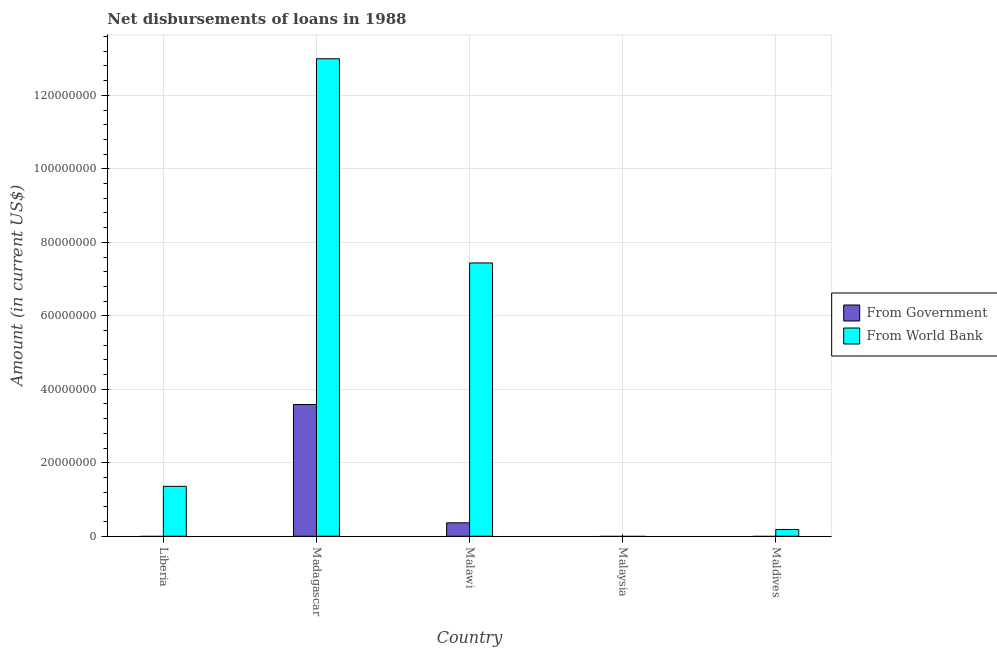Are the number of bars per tick equal to the number of legend labels?
Keep it short and to the point. No. Are the number of bars on each tick of the X-axis equal?
Ensure brevity in your answer.  No. How many bars are there on the 1st tick from the left?
Offer a very short reply. 1. How many bars are there on the 1st tick from the right?
Your answer should be very brief. 1. What is the label of the 5th group of bars from the left?
Ensure brevity in your answer.  Maldives. In how many cases, is the number of bars for a given country not equal to the number of legend labels?
Your answer should be compact. 3. What is the net disbursements of loan from government in Maldives?
Make the answer very short. 0. Across all countries, what is the maximum net disbursements of loan from world bank?
Your answer should be very brief. 1.30e+08. In which country was the net disbursements of loan from government maximum?
Offer a terse response. Madagascar. What is the total net disbursements of loan from government in the graph?
Offer a terse response. 3.95e+07. What is the difference between the net disbursements of loan from world bank in Madagascar and that in Malawi?
Make the answer very short. 5.56e+07. What is the difference between the net disbursements of loan from government in Maldives and the net disbursements of loan from world bank in Malawi?
Make the answer very short. -7.44e+07. What is the average net disbursements of loan from government per country?
Give a very brief answer. 7.90e+06. What is the difference between the net disbursements of loan from government and net disbursements of loan from world bank in Malawi?
Offer a very short reply. -7.07e+07. In how many countries, is the net disbursements of loan from government greater than 112000000 US$?
Keep it short and to the point. 0. What is the ratio of the net disbursements of loan from world bank in Malawi to that in Maldives?
Ensure brevity in your answer.  40.38. Is the net disbursements of loan from world bank in Malawi less than that in Maldives?
Your answer should be compact. No. Is the difference between the net disbursements of loan from world bank in Madagascar and Malawi greater than the difference between the net disbursements of loan from government in Madagascar and Malawi?
Provide a short and direct response. Yes. What is the difference between the highest and the second highest net disbursements of loan from world bank?
Offer a terse response. 5.56e+07. What is the difference between the highest and the lowest net disbursements of loan from world bank?
Keep it short and to the point. 1.30e+08. In how many countries, is the net disbursements of loan from government greater than the average net disbursements of loan from government taken over all countries?
Make the answer very short. 1. Is the sum of the net disbursements of loan from world bank in Malawi and Maldives greater than the maximum net disbursements of loan from government across all countries?
Provide a succinct answer. Yes. How many bars are there?
Your answer should be compact. 6. How many countries are there in the graph?
Make the answer very short. 5. What is the difference between two consecutive major ticks on the Y-axis?
Provide a succinct answer. 2.00e+07. Does the graph contain grids?
Your response must be concise. Yes. Where does the legend appear in the graph?
Offer a very short reply. Center right. How many legend labels are there?
Give a very brief answer. 2. How are the legend labels stacked?
Ensure brevity in your answer.  Vertical. What is the title of the graph?
Offer a terse response. Net disbursements of loans in 1988. Does "Age 65(female)" appear as one of the legend labels in the graph?
Your response must be concise. No. What is the label or title of the Y-axis?
Make the answer very short. Amount (in current US$). What is the Amount (in current US$) in From World Bank in Liberia?
Your answer should be compact. 1.36e+07. What is the Amount (in current US$) in From Government in Madagascar?
Keep it short and to the point. 3.59e+07. What is the Amount (in current US$) in From World Bank in Madagascar?
Your answer should be compact. 1.30e+08. What is the Amount (in current US$) in From Government in Malawi?
Provide a short and direct response. 3.66e+06. What is the Amount (in current US$) of From World Bank in Malawi?
Keep it short and to the point. 7.44e+07. What is the Amount (in current US$) of From Government in Maldives?
Offer a terse response. 0. What is the Amount (in current US$) of From World Bank in Maldives?
Ensure brevity in your answer.  1.84e+06. Across all countries, what is the maximum Amount (in current US$) of From Government?
Keep it short and to the point. 3.59e+07. Across all countries, what is the maximum Amount (in current US$) of From World Bank?
Provide a short and direct response. 1.30e+08. What is the total Amount (in current US$) in From Government in the graph?
Provide a short and direct response. 3.95e+07. What is the total Amount (in current US$) of From World Bank in the graph?
Make the answer very short. 2.20e+08. What is the difference between the Amount (in current US$) in From World Bank in Liberia and that in Madagascar?
Offer a terse response. -1.16e+08. What is the difference between the Amount (in current US$) in From World Bank in Liberia and that in Malawi?
Offer a terse response. -6.08e+07. What is the difference between the Amount (in current US$) of From World Bank in Liberia and that in Maldives?
Give a very brief answer. 1.17e+07. What is the difference between the Amount (in current US$) of From Government in Madagascar and that in Malawi?
Provide a short and direct response. 3.22e+07. What is the difference between the Amount (in current US$) in From World Bank in Madagascar and that in Malawi?
Keep it short and to the point. 5.56e+07. What is the difference between the Amount (in current US$) in From World Bank in Madagascar and that in Maldives?
Give a very brief answer. 1.28e+08. What is the difference between the Amount (in current US$) of From World Bank in Malawi and that in Maldives?
Give a very brief answer. 7.25e+07. What is the difference between the Amount (in current US$) of From Government in Madagascar and the Amount (in current US$) of From World Bank in Malawi?
Provide a short and direct response. -3.85e+07. What is the difference between the Amount (in current US$) of From Government in Madagascar and the Amount (in current US$) of From World Bank in Maldives?
Provide a short and direct response. 3.40e+07. What is the difference between the Amount (in current US$) in From Government in Malawi and the Amount (in current US$) in From World Bank in Maldives?
Offer a very short reply. 1.82e+06. What is the average Amount (in current US$) of From Government per country?
Your answer should be very brief. 7.90e+06. What is the average Amount (in current US$) of From World Bank per country?
Offer a terse response. 4.40e+07. What is the difference between the Amount (in current US$) in From Government and Amount (in current US$) in From World Bank in Madagascar?
Offer a very short reply. -9.41e+07. What is the difference between the Amount (in current US$) of From Government and Amount (in current US$) of From World Bank in Malawi?
Ensure brevity in your answer.  -7.07e+07. What is the ratio of the Amount (in current US$) of From World Bank in Liberia to that in Madagascar?
Make the answer very short. 0.1. What is the ratio of the Amount (in current US$) in From World Bank in Liberia to that in Malawi?
Give a very brief answer. 0.18. What is the ratio of the Amount (in current US$) of From World Bank in Liberia to that in Maldives?
Provide a short and direct response. 7.37. What is the ratio of the Amount (in current US$) in From Government in Madagascar to that in Malawi?
Your response must be concise. 9.8. What is the ratio of the Amount (in current US$) in From World Bank in Madagascar to that in Malawi?
Make the answer very short. 1.75. What is the ratio of the Amount (in current US$) of From World Bank in Madagascar to that in Maldives?
Provide a succinct answer. 70.55. What is the ratio of the Amount (in current US$) in From World Bank in Malawi to that in Maldives?
Your answer should be very brief. 40.38. What is the difference between the highest and the second highest Amount (in current US$) of From World Bank?
Make the answer very short. 5.56e+07. What is the difference between the highest and the lowest Amount (in current US$) in From Government?
Offer a very short reply. 3.59e+07. What is the difference between the highest and the lowest Amount (in current US$) of From World Bank?
Make the answer very short. 1.30e+08. 